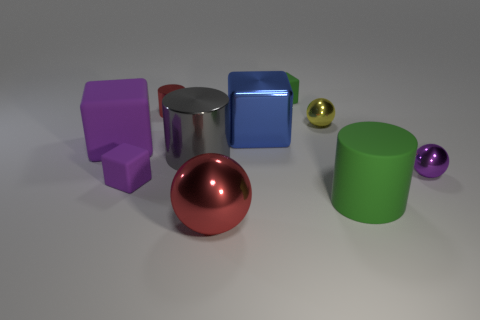What is the shape of the matte object behind the blue metal object?
Keep it short and to the point. Cube. How many blue things are big rubber blocks or big balls?
Provide a short and direct response. 0. There is a big cylinder that is made of the same material as the small yellow object; what color is it?
Your response must be concise. Gray. Does the matte cylinder have the same color as the large cube that is right of the red metallic cylinder?
Offer a very short reply. No. There is a small shiny thing that is both on the right side of the blue object and behind the small purple shiny sphere; what color is it?
Your answer should be compact. Yellow. How many tiny balls are behind the green matte cylinder?
Your answer should be compact. 2. How many things are either large metallic balls or metal objects behind the large metal sphere?
Ensure brevity in your answer.  6. There is a shiny sphere that is in front of the tiny purple matte cube; is there a metallic cylinder on the left side of it?
Your response must be concise. Yes. The metallic sphere that is to the left of the small green rubber object is what color?
Keep it short and to the point. Red. Are there the same number of gray metallic objects that are in front of the green rubber cylinder and tiny purple matte cubes?
Your response must be concise. No. 